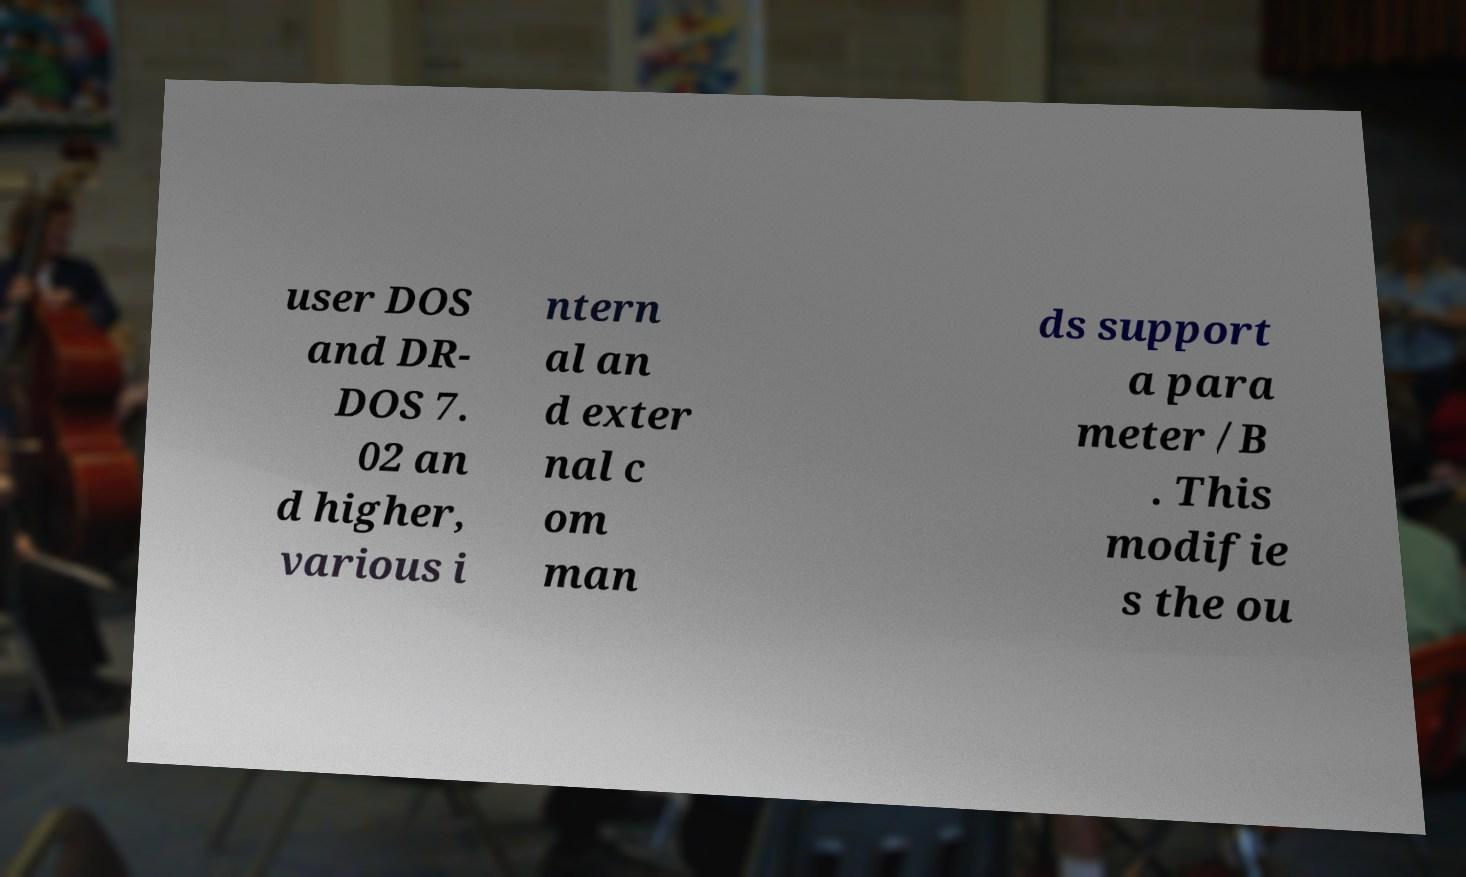Please read and relay the text visible in this image. What does it say? user DOS and DR- DOS 7. 02 an d higher, various i ntern al an d exter nal c om man ds support a para meter /B . This modifie s the ou 